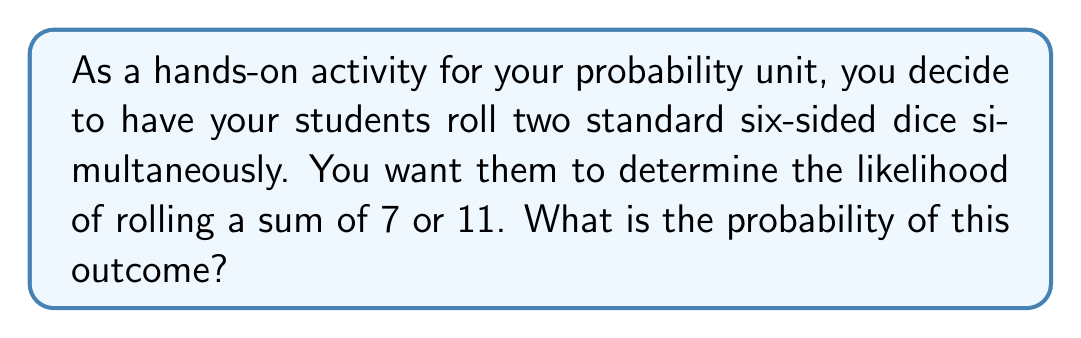Show me your answer to this math problem. Let's approach this step-by-step using a real-world manipulative approach:

1) First, let's consider all possible outcomes when rolling two dice:
   - There are 6 possible outcomes on each die.
   - The total number of possible outcomes is thus $6 \times 6 = 36$.

2) Now, let's count the favorable outcomes:
   - To get a sum of 7, we can have:
     (1,6), (2,5), (3,4), (4,3), (5,2), (6,1)
     That's 6 ways to get a sum of 7.
   - To get a sum of 11, we can have:
     (5,6), (6,5)
     That's 2 ways to get a sum of 11.

3) Total favorable outcomes:
   $6 + 2 = 8$

4) The probability is then:

   $$P(\text{sum of 7 or 11}) = \frac{\text{favorable outcomes}}{\text{total outcomes}} = \frac{8}{36} = \frac{2}{9}$$

This problem can be demonstrated in class using actual dice. Students can roll the dice multiple times and tally their results, comparing their experimental probability to the theoretical probability we've calculated.
Answer: $\frac{2}{9}$ or approximately 0.2222 or 22.22% 